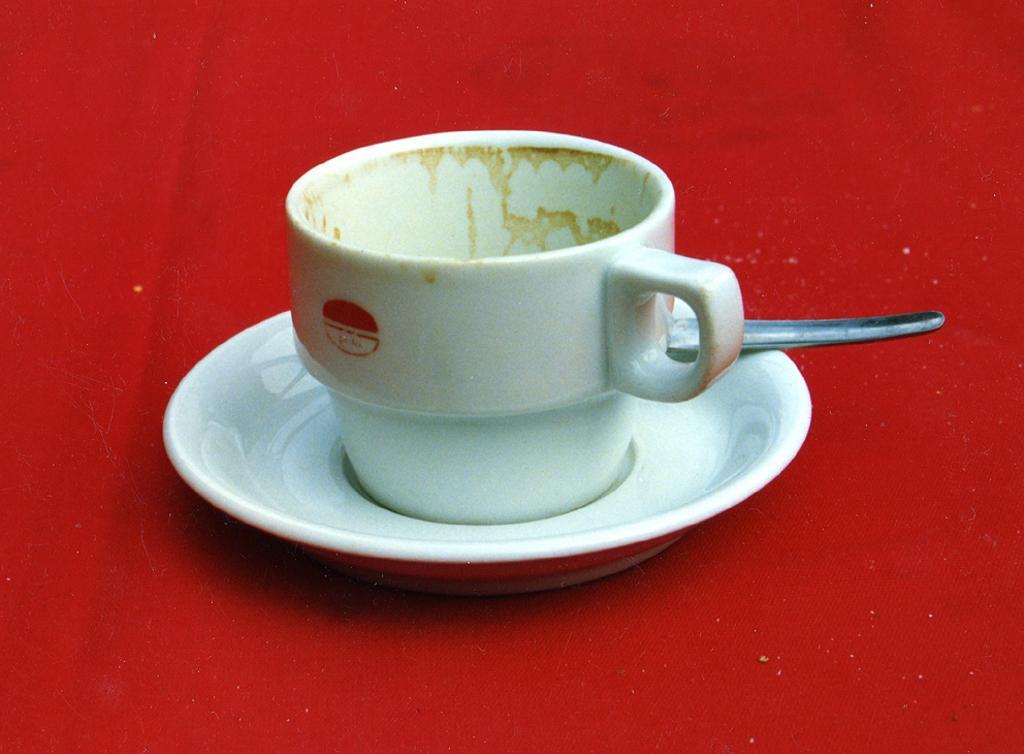Describe this image in one or two sentences. This image consists of cup, saucer. It is placed on red cloth. 